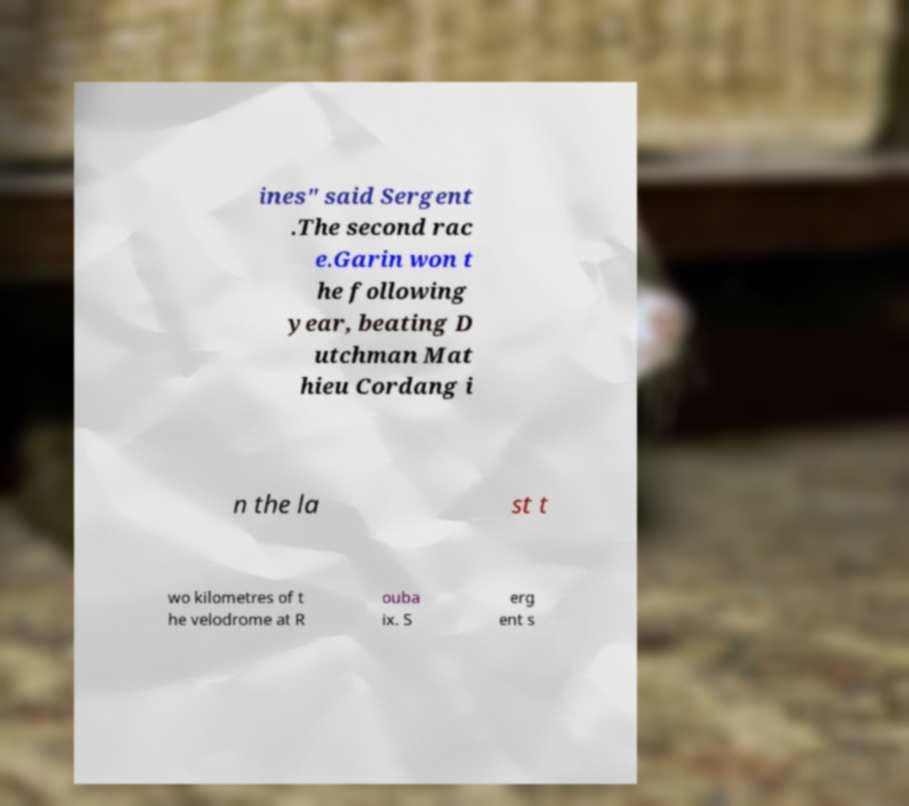There's text embedded in this image that I need extracted. Can you transcribe it verbatim? ines" said Sergent .The second rac e.Garin won t he following year, beating D utchman Mat hieu Cordang i n the la st t wo kilometres of t he velodrome at R ouba ix. S erg ent s 